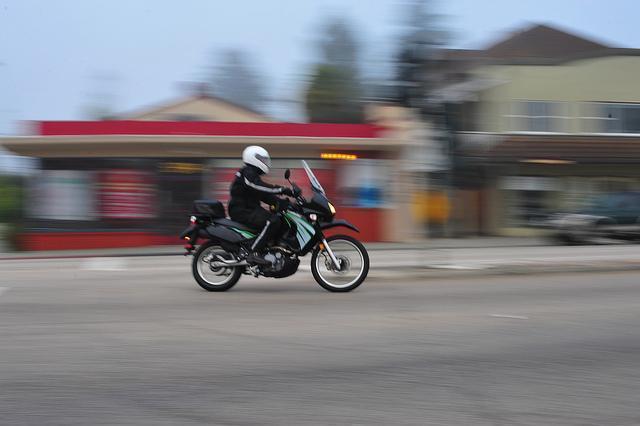Why is the man wearing a white helmet?
Choose the right answer from the provided options to respond to the question.
Options: Protection, visibility, dress code, fashion. Protection. 